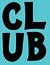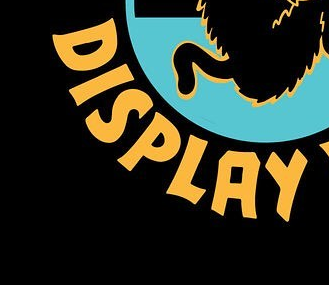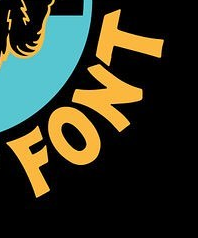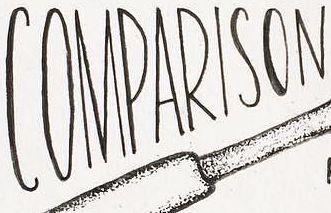What text is displayed in these images sequentially, separated by a semicolon? CLUB; DISPLAY; FONT; COMPARISON 